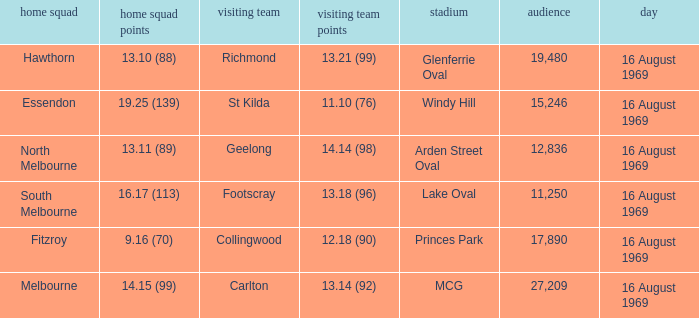What was the away team's score at Princes Park? 12.18 (90). Parse the full table. {'header': ['home squad', 'home squad points', 'visiting team', 'visiting team points', 'stadium', 'audience', 'day'], 'rows': [['Hawthorn', '13.10 (88)', 'Richmond', '13.21 (99)', 'Glenferrie Oval', '19,480', '16 August 1969'], ['Essendon', '19.25 (139)', 'St Kilda', '11.10 (76)', 'Windy Hill', '15,246', '16 August 1969'], ['North Melbourne', '13.11 (89)', 'Geelong', '14.14 (98)', 'Arden Street Oval', '12,836', '16 August 1969'], ['South Melbourne', '16.17 (113)', 'Footscray', '13.18 (96)', 'Lake Oval', '11,250', '16 August 1969'], ['Fitzroy', '9.16 (70)', 'Collingwood', '12.18 (90)', 'Princes Park', '17,890', '16 August 1969'], ['Melbourne', '14.15 (99)', 'Carlton', '13.14 (92)', 'MCG', '27,209', '16 August 1969']]} 